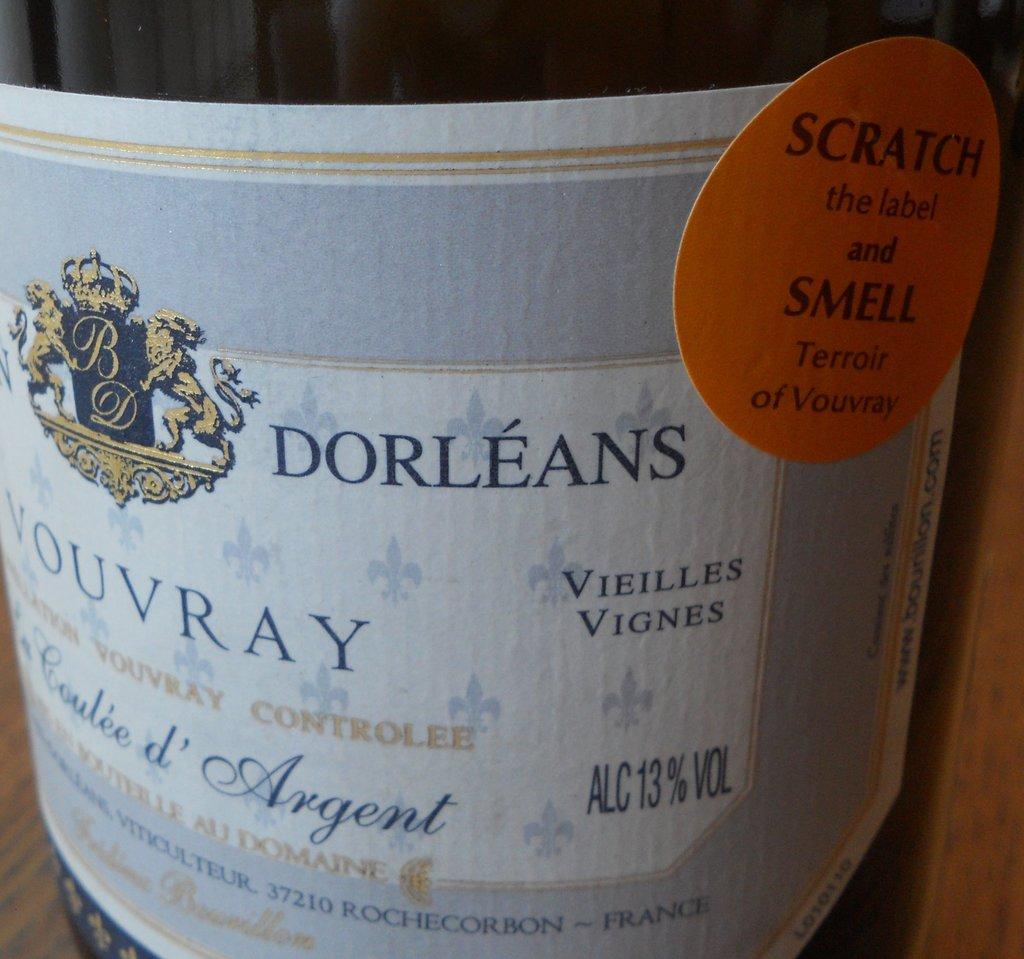What do you do to smell?
Make the answer very short. Scratch. What is the alcohol content of this wine?
Provide a short and direct response. 13%. 